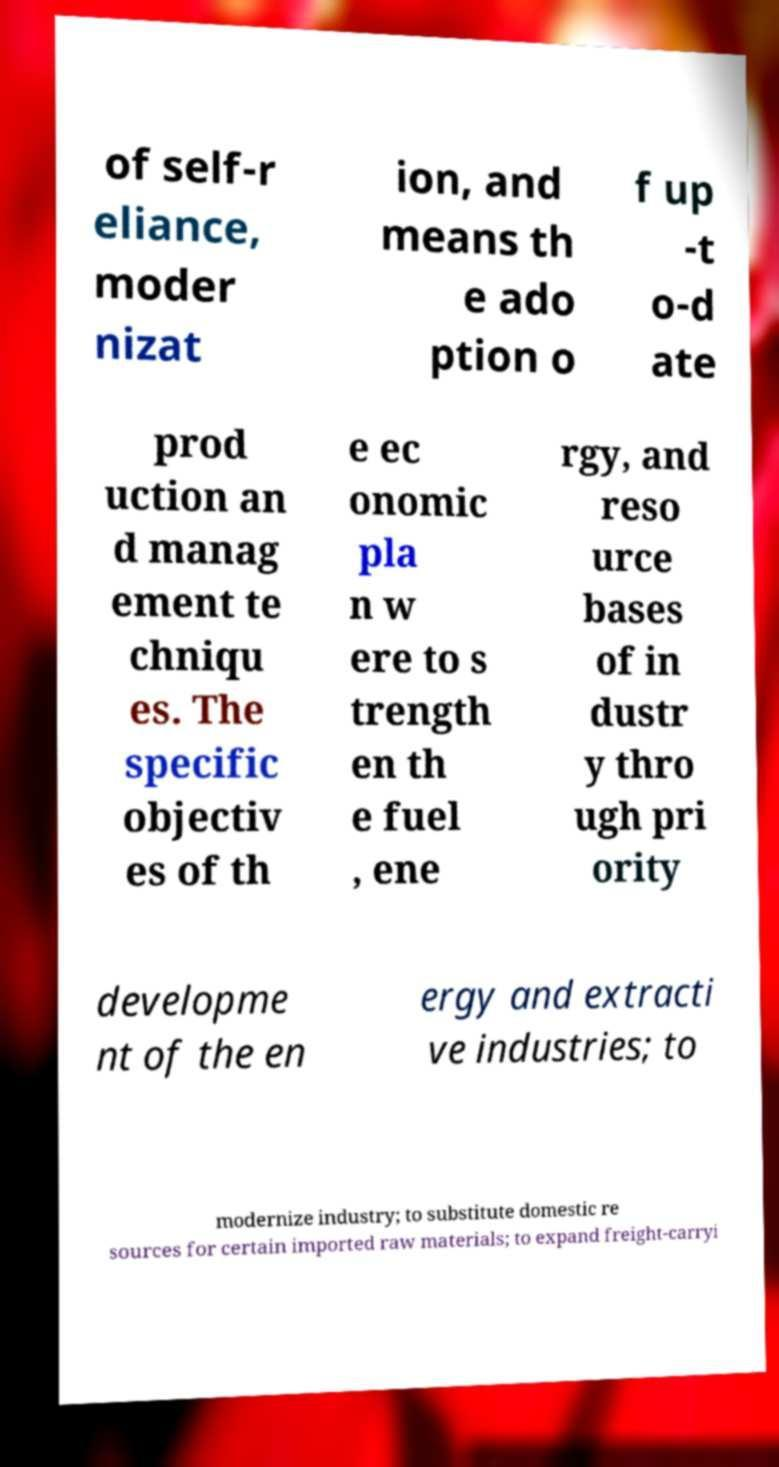What messages or text are displayed in this image? I need them in a readable, typed format. of self-r eliance, moder nizat ion, and means th e ado ption o f up -t o-d ate prod uction an d manag ement te chniqu es. The specific objectiv es of th e ec onomic pla n w ere to s trength en th e fuel , ene rgy, and reso urce bases of in dustr y thro ugh pri ority developme nt of the en ergy and extracti ve industries; to modernize industry; to substitute domestic re sources for certain imported raw materials; to expand freight-carryi 